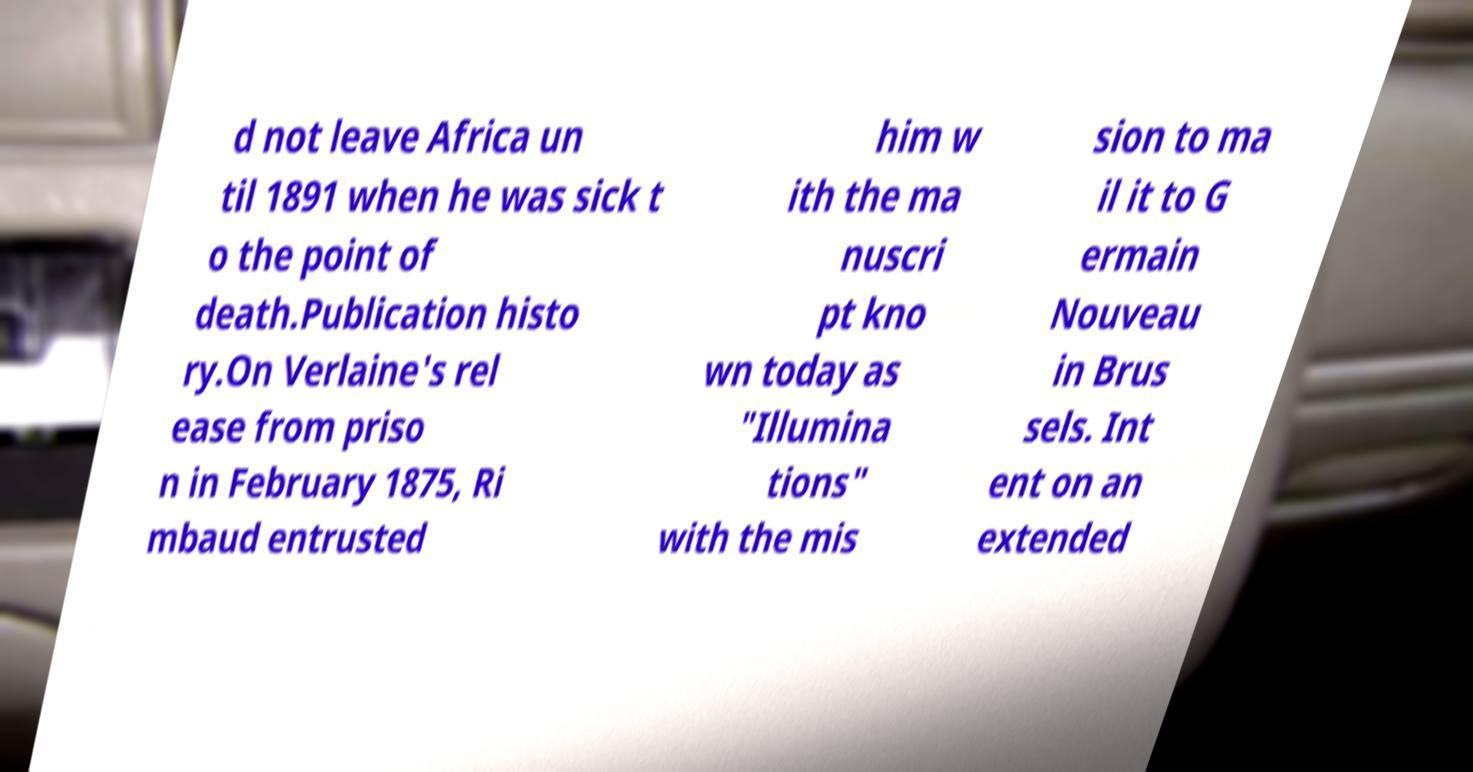Could you extract and type out the text from this image? d not leave Africa un til 1891 when he was sick t o the point of death.Publication histo ry.On Verlaine's rel ease from priso n in February 1875, Ri mbaud entrusted him w ith the ma nuscri pt kno wn today as "Illumina tions" with the mis sion to ma il it to G ermain Nouveau in Brus sels. Int ent on an extended 